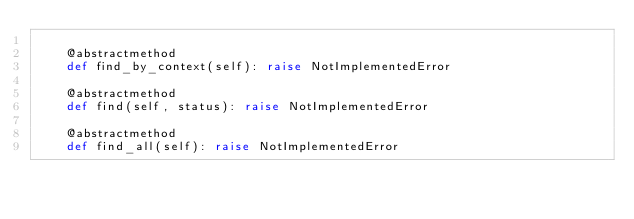<code> <loc_0><loc_0><loc_500><loc_500><_Python_>
    @abstractmethod
    def find_by_context(self): raise NotImplementedError

    @abstractmethod
    def find(self, status): raise NotImplementedError

    @abstractmethod
    def find_all(self): raise NotImplementedError
</code> 